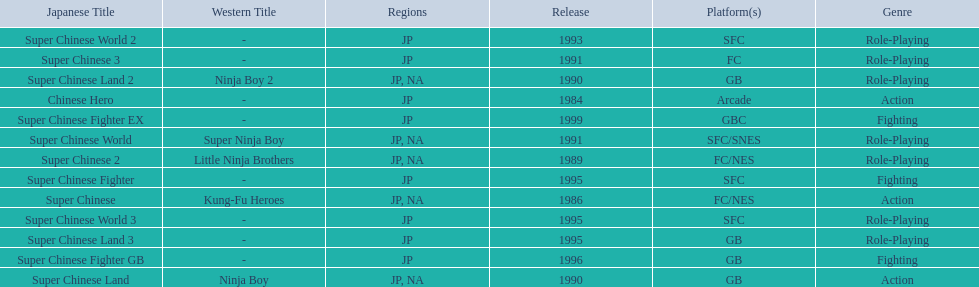Which titles were released in north america? Super Chinese, Super Chinese 2, Super Chinese Land, Super Chinese Land 2, Super Chinese World. Of those, which had the least releases? Super Chinese World. 